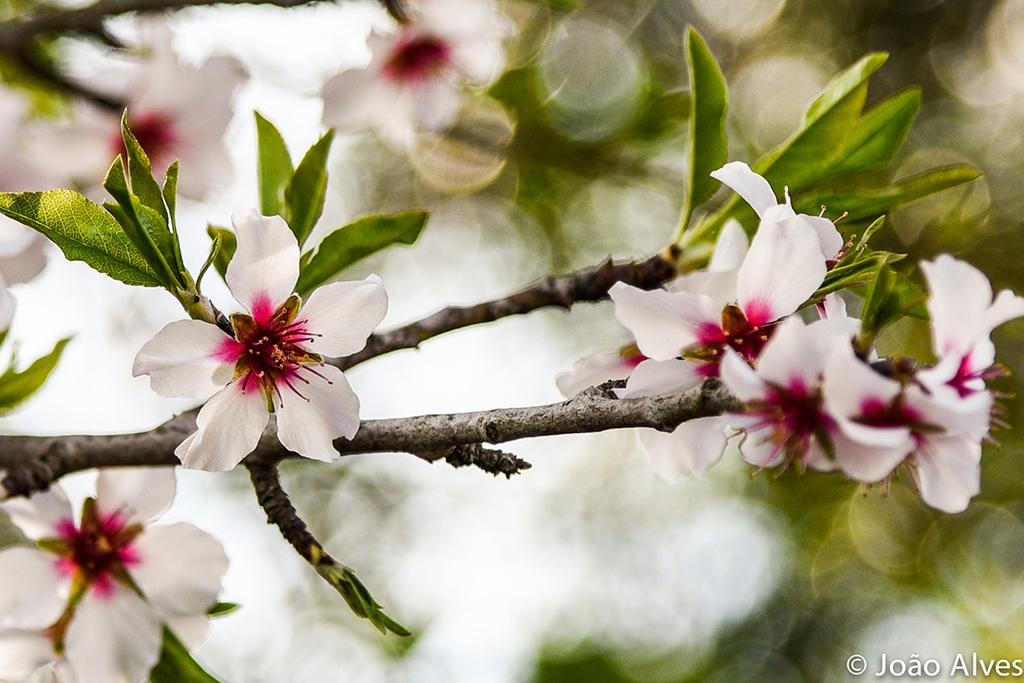What type of plants can be seen in the image? There are flowers, leaves, and branches in the image. What is the background of the image like? The background of the image is blurry. Where is the text located in the image? The text is in the bottom right side of the image. What type of tank can be seen in the image? There is no tank present in the image. Is there a tub filled with water in the image? There is no tub filled with water in the image. 